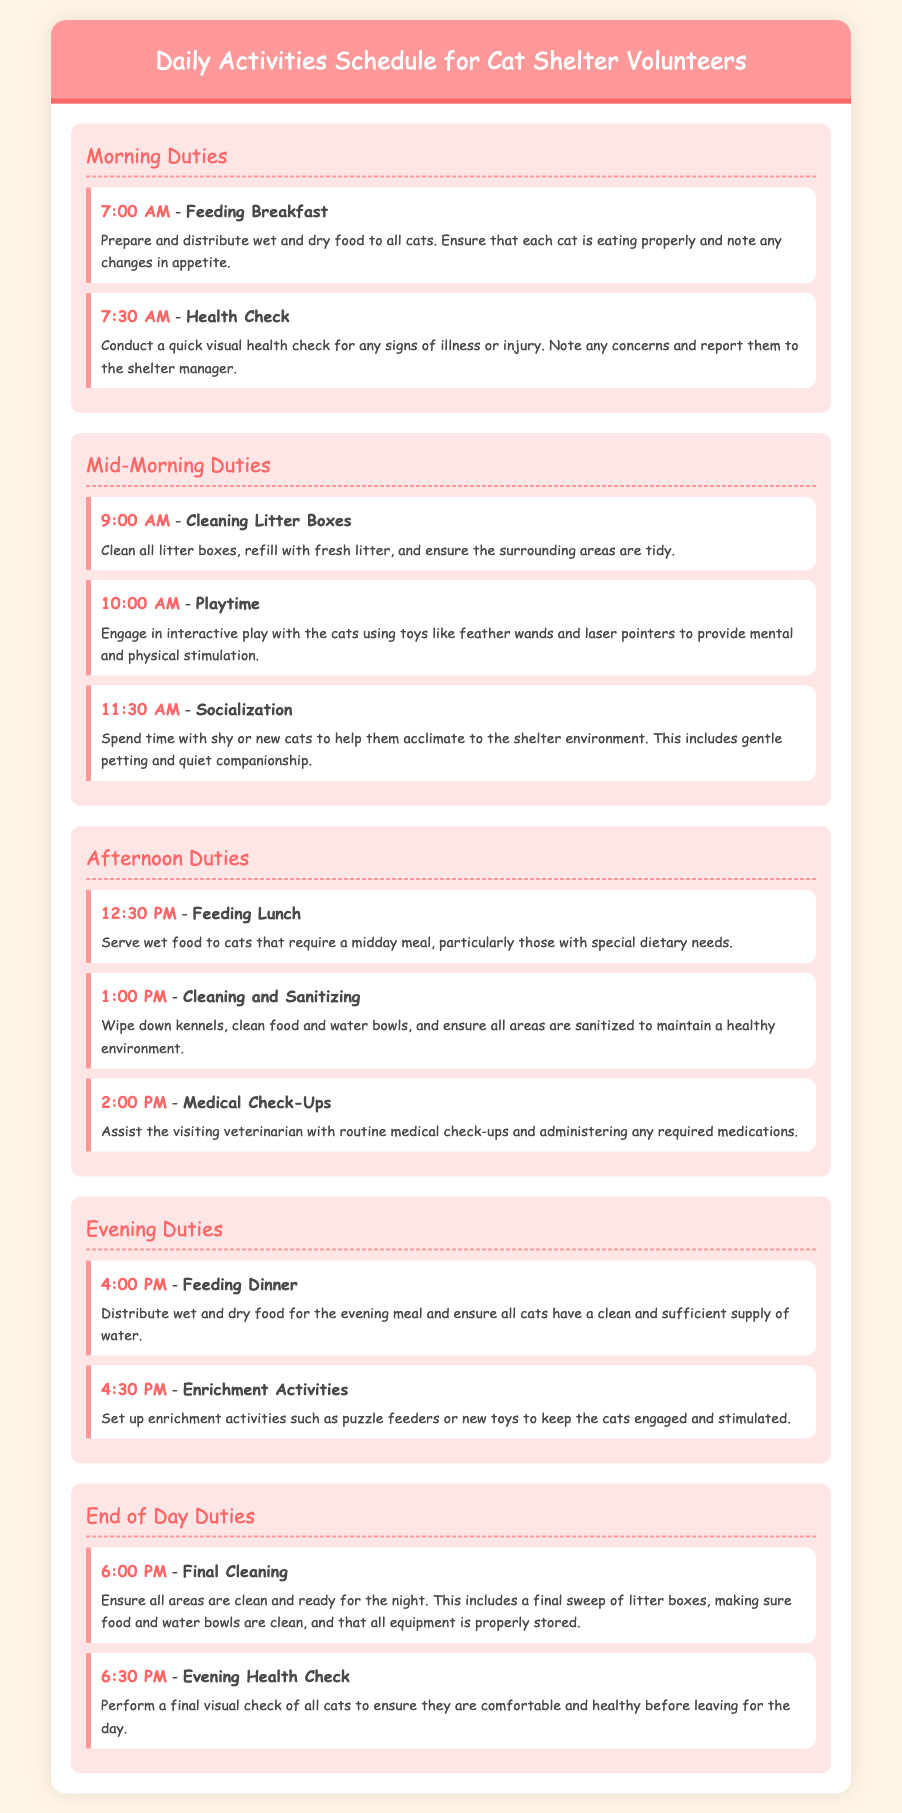what time is breakfast served? Breakfast is served at 7:00 AM according to the Morning Duties section of the schedule.
Answer: 7:00 AM how many playtime sessions are scheduled? The document indicates one playtime session scheduled in the Mid-Morning Duties section at 10:00 AM.
Answer: One what activity follows the Cleaning Litter Boxes? After Cleaning Litter Boxes at 9:00 AM, the next activity is Playtime at 10:00 AM.
Answer: Playtime what is the last activity listed in the schedule? The last activity listed is the Evening Health Check at 6:30 PM in the End of Day Duties section.
Answer: Evening Health Check what type of food is served for lunch? The lunch served consists of wet food for cats that require a midday meal.
Answer: Wet food what is the main purpose of the Enrichment Activities? The main purpose of Enrichment Activities is to keep the cats engaged and stimulated as indicated in the Evening Duties section.
Answer: Engagement and stimulation how often are medical check-ups conducted? Medical check-ups are conducted once a day in the Afternoon Duties section at 2:00 PM.
Answer: Once a day what time is final cleaning scheduled? Final cleaning is scheduled for 6:00 PM in the End of Day Duties section.
Answer: 6:00 PM 